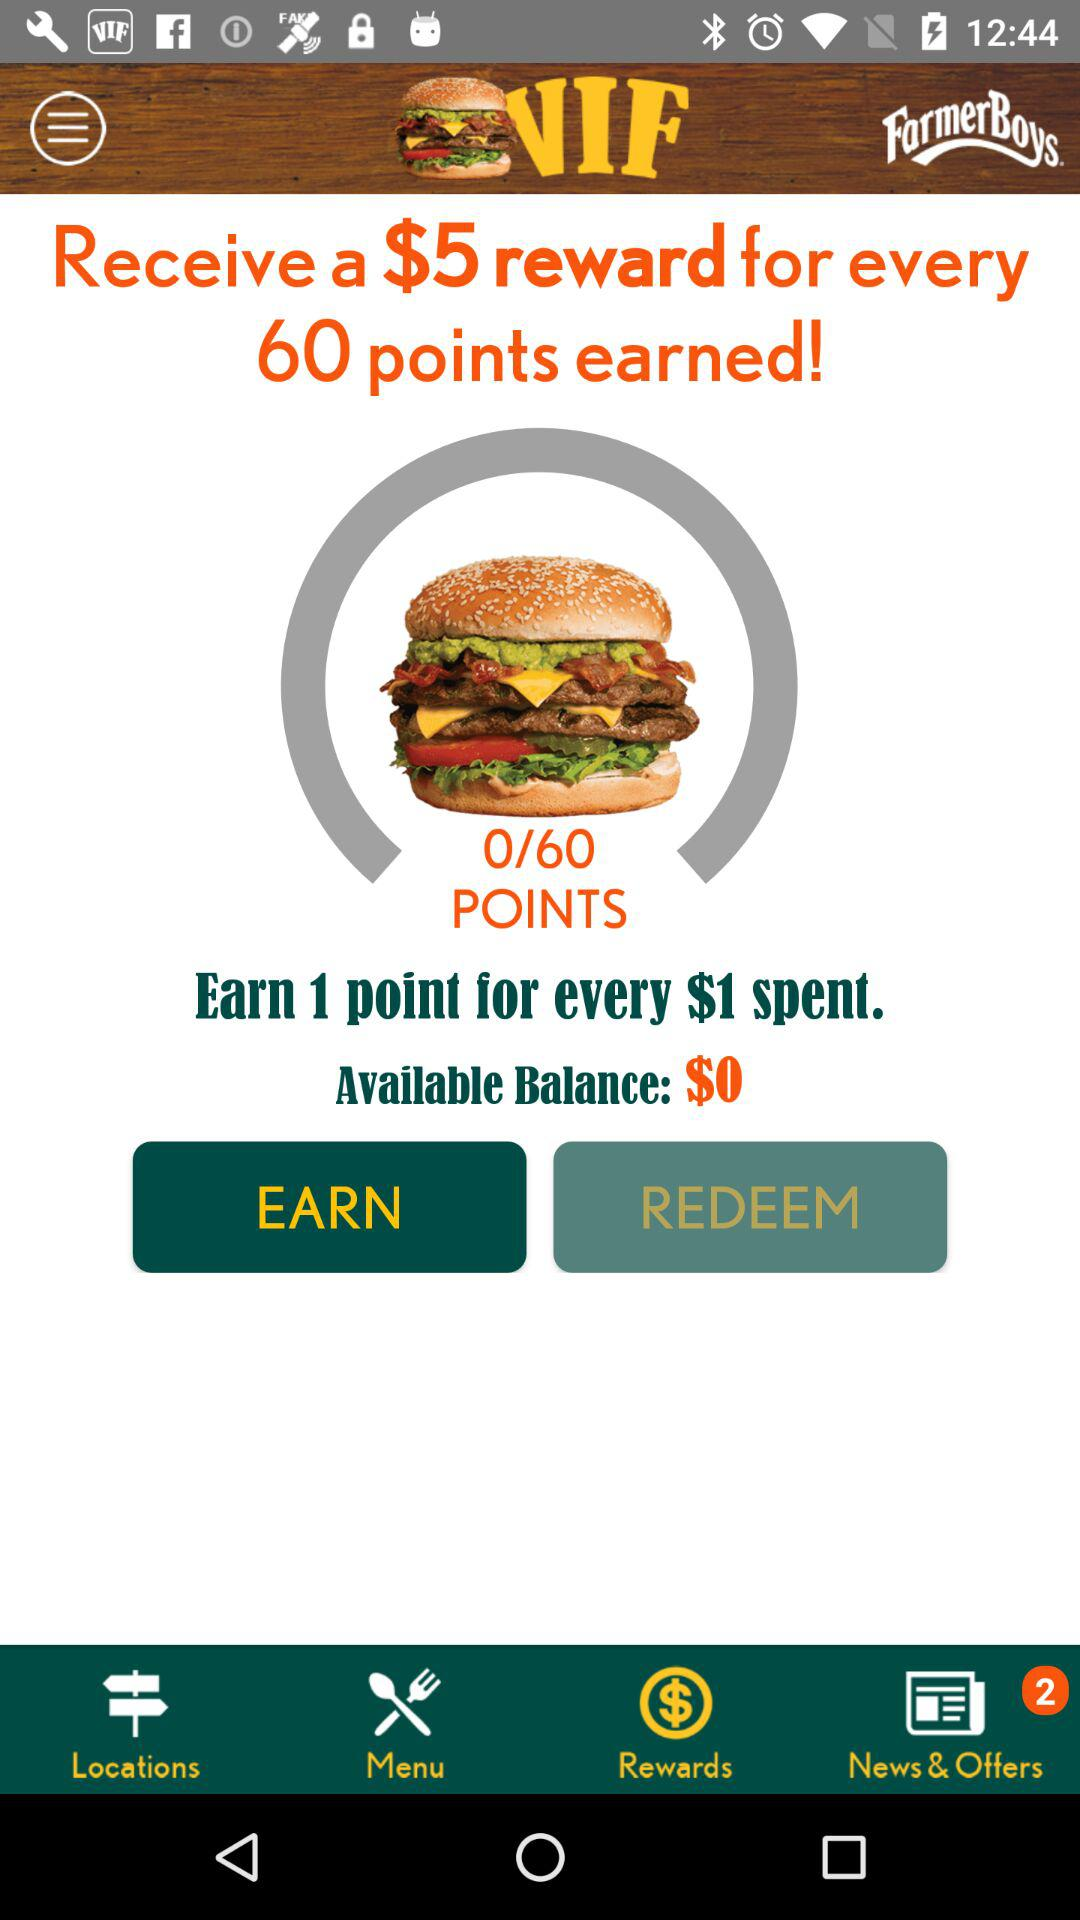How much money do we get on 60 points earned? For every 60 points earned, you will receive $5. 